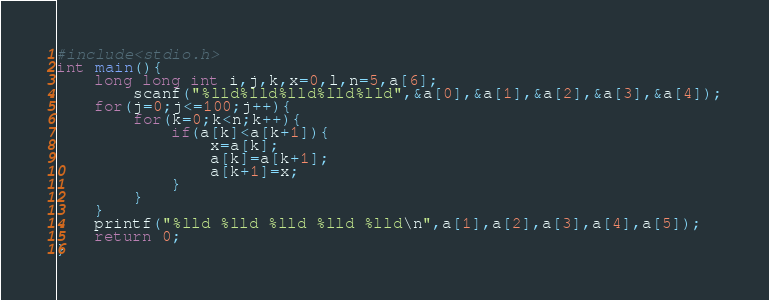<code> <loc_0><loc_0><loc_500><loc_500><_C_>#include<stdio.h>
int main(){
    long long int i,j,k,x=0,l,n=5,a[6];
        scanf("%lld%lld%lld%lld%lld",&a[0],&a[1],&a[2],&a[3],&a[4]);
    for(j=0;j<=100;j++){
        for(k=0;k<n;k++){
            if(a[k]<a[k+1]){
                x=a[k];
                a[k]=a[k+1];
                a[k+1]=x;
            }
        }
    }
    printf("%lld %lld %lld %lld %lld\n",a[1],a[2],a[3],a[4],a[5]);
    return 0;
}</code> 